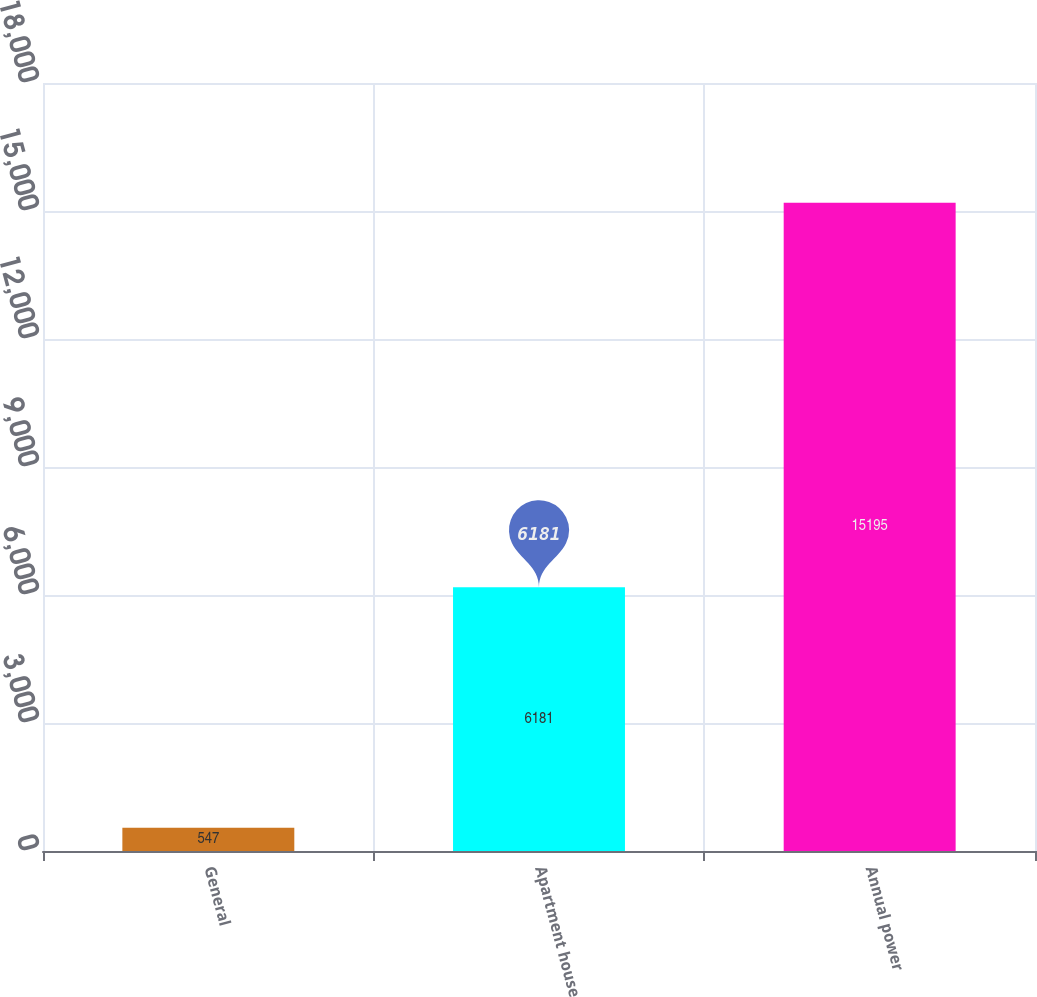Convert chart to OTSL. <chart><loc_0><loc_0><loc_500><loc_500><bar_chart><fcel>General<fcel>Apartment house<fcel>Annual power<nl><fcel>547<fcel>6181<fcel>15195<nl></chart> 